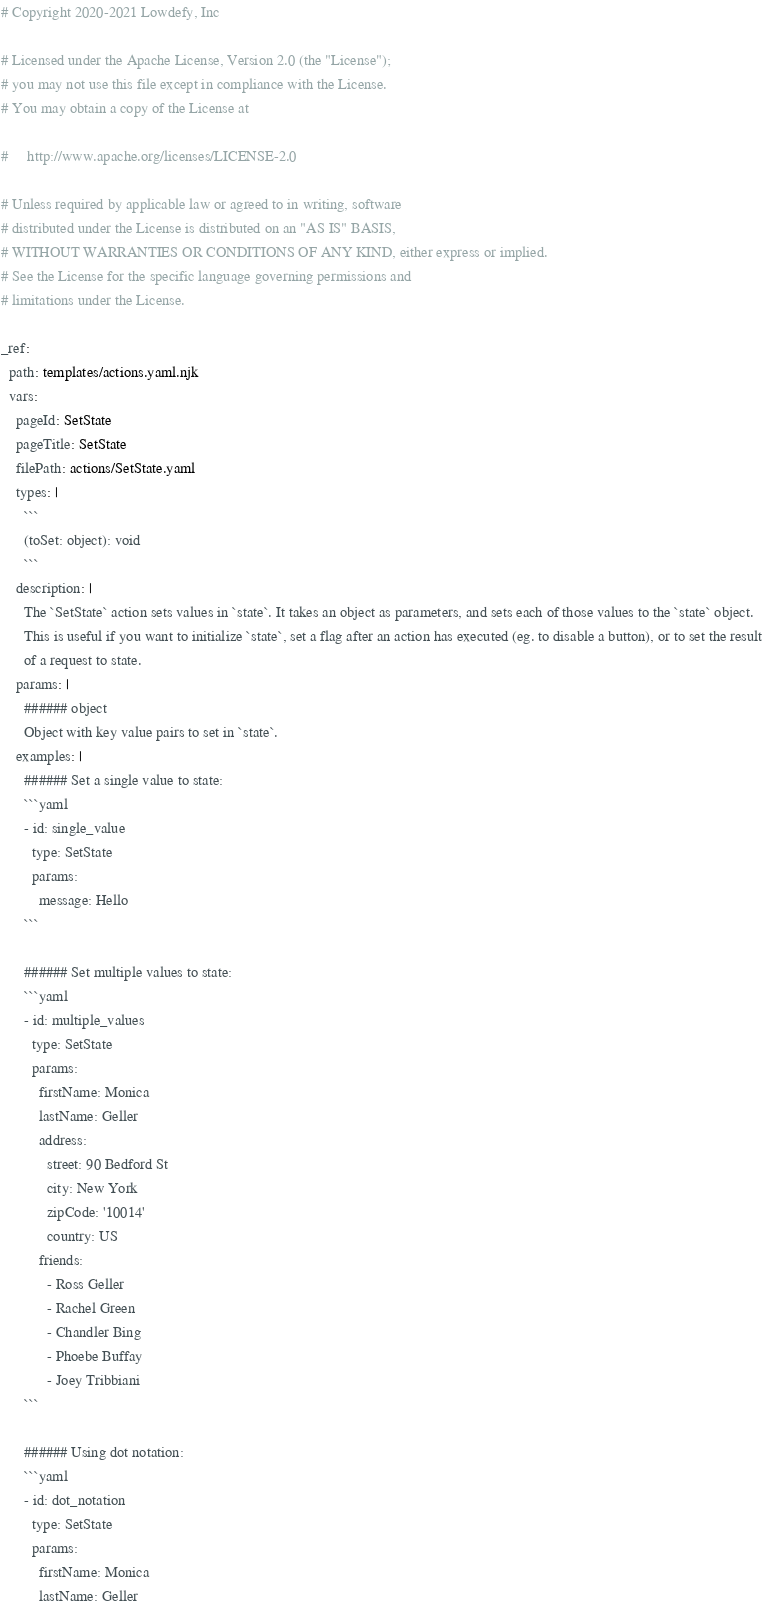<code> <loc_0><loc_0><loc_500><loc_500><_YAML_># Copyright 2020-2021 Lowdefy, Inc

# Licensed under the Apache License, Version 2.0 (the "License");
# you may not use this file except in compliance with the License.
# You may obtain a copy of the License at

#     http://www.apache.org/licenses/LICENSE-2.0

# Unless required by applicable law or agreed to in writing, software
# distributed under the License is distributed on an "AS IS" BASIS,
# WITHOUT WARRANTIES OR CONDITIONS OF ANY KIND, either express or implied.
# See the License for the specific language governing permissions and
# limitations under the License.

_ref:
  path: templates/actions.yaml.njk
  vars:
    pageId: SetState
    pageTitle: SetState
    filePath: actions/SetState.yaml
    types: |
      ```
      (toSet: object): void
      ```
    description: |
      The `SetState` action sets values in `state`. It takes an object as parameters, and sets each of those values to the `state` object.
      This is useful if you want to initialize `state`, set a flag after an action has executed (eg. to disable a button), or to set the result
      of a request to state.
    params: |
      ###### object
      Object with key value pairs to set in `state`.
    examples: |
      ###### Set a single value to state:
      ```yaml
      - id: single_value
        type: SetState
        params:
          message: Hello
      ```

      ###### Set multiple values to state:
      ```yaml
      - id: multiple_values
        type: SetState
        params:
          firstName: Monica
          lastName: Geller
          address:
            street: 90 Bedford St
            city: New York
            zipCode: '10014'
            country: US
          friends:
            - Ross Geller
            - Rachel Green
            - Chandler Bing
            - Phoebe Buffay
            - Joey Tribbiani
      ```

      ###### Using dot notation:
      ```yaml
      - id: dot_notation
        type: SetState
        params:
          firstName: Monica
          lastName: Geller</code> 